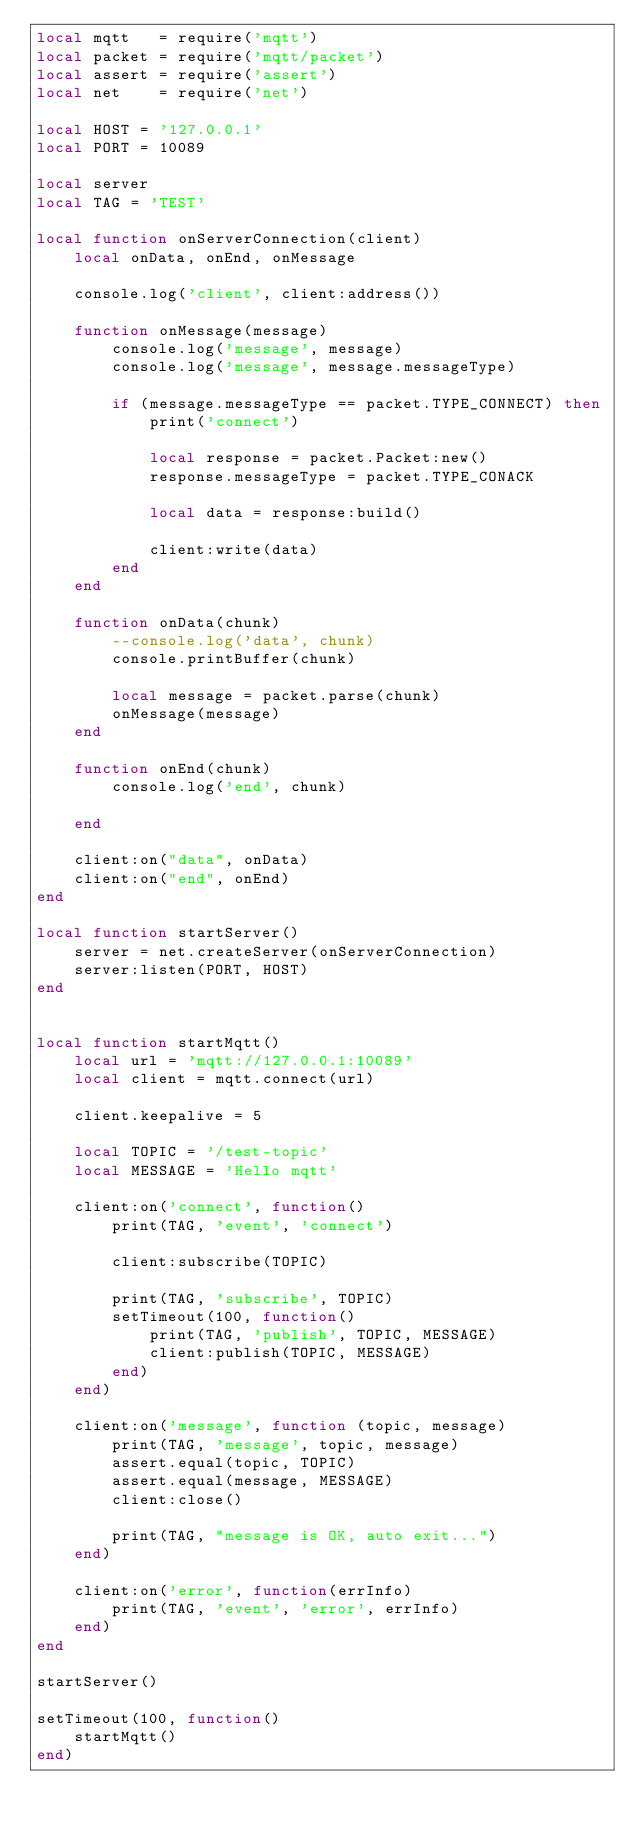Convert code to text. <code><loc_0><loc_0><loc_500><loc_500><_Lua_>local mqtt   = require('mqtt')
local packet = require('mqtt/packet')
local assert = require('assert')
local net    = require('net')

local HOST = '127.0.0.1'
local PORT = 10089

local server
local TAG = 'TEST'

local function onServerConnection(client)
    local onData, onEnd, onMessage

    console.log('client', client:address())

    function onMessage(message)
        console.log('message', message)
        console.log('message', message.messageType)

        if (message.messageType == packet.TYPE_CONNECT) then
            print('connect')

            local response = packet.Packet:new()
            response.messageType = packet.TYPE_CONACK

            local data = response:build()

            client:write(data)
        end
    end

    function onData(chunk)
        --console.log('data', chunk)
        console.printBuffer(chunk)

        local message = packet.parse(chunk)
        onMessage(message)
    end

    function onEnd(chunk)
        console.log('end', chunk)

    end

    client:on("data", onData)
    client:on("end", onEnd)
end

local function startServer()
    server = net.createServer(onServerConnection)
    server:listen(PORT, HOST)
end


local function startMqtt()
    local url = 'mqtt://127.0.0.1:10089'
    local client = mqtt.connect(url)

    client.keepalive = 5

    local TOPIC = '/test-topic'
    local MESSAGE = 'Hello mqtt'

    client:on('connect', function()
        print(TAG, 'event', 'connect')

        client:subscribe(TOPIC)

        print(TAG, 'subscribe', TOPIC)
        setTimeout(100, function()
            print(TAG, 'publish', TOPIC, MESSAGE)
            client:publish(TOPIC, MESSAGE)
        end)
    end)

    client:on('message', function (topic, message)
        print(TAG, 'message', topic, message)
        assert.equal(topic, TOPIC)
        assert.equal(message, MESSAGE)
        client:close()

        print(TAG, "message is OK, auto exit...")
    end)

    client:on('error', function(errInfo)
        print(TAG, 'event', 'error', errInfo)
    end)
end

startServer()

setTimeout(100, function()
    startMqtt()
end)
</code> 